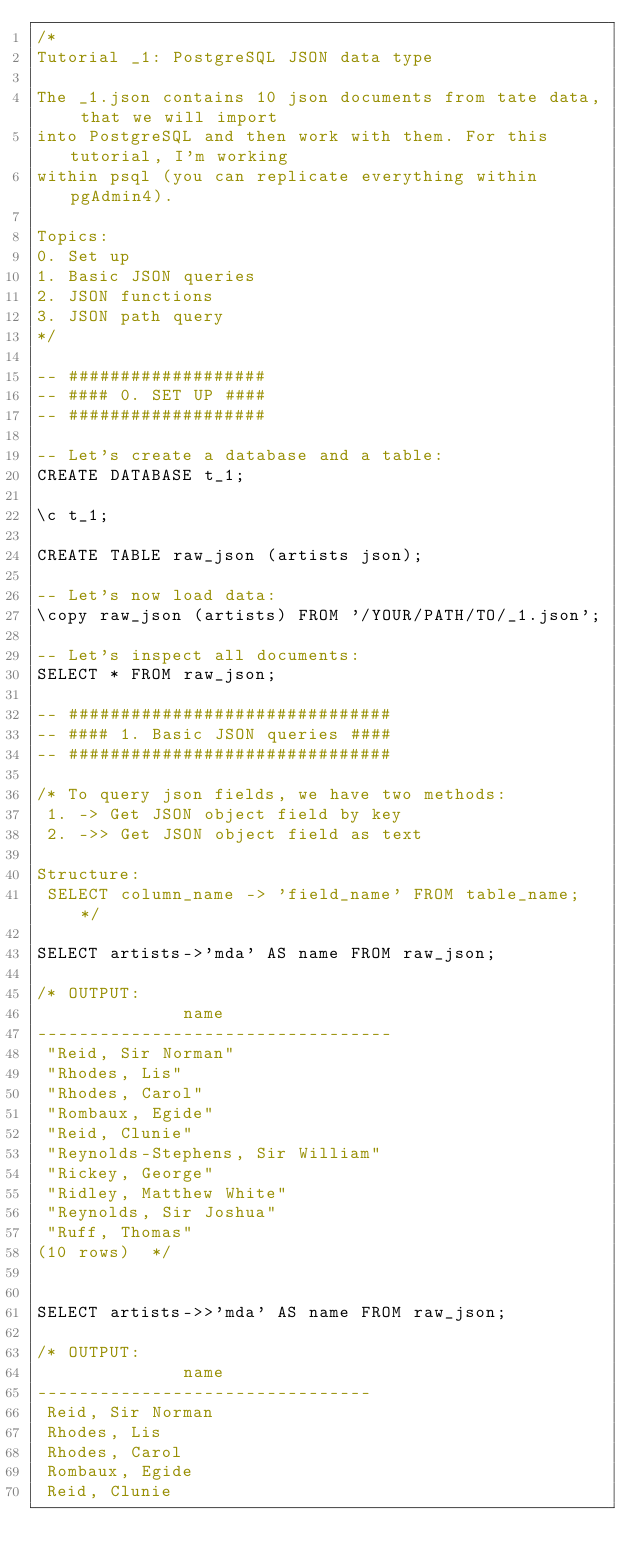Convert code to text. <code><loc_0><loc_0><loc_500><loc_500><_SQL_>/*
Tutorial _1: PostgreSQL JSON data type

The _1.json contains 10 json documents from tate data, that we will import
into PostgreSQL and then work with them. For this tutorial, I'm working
within psql (you can replicate everything within pgAdmin4).

Topics:
0. Set up
1. Basic JSON queries
2. JSON functions
3. JSON path query
*/

-- ###################
-- #### 0. SET UP ####
-- ###################

-- Let's create a database and a table:
CREATE DATABASE t_1;

\c t_1;

CREATE TABLE raw_json (artists json);

-- Let's now load data:
\copy raw_json (artists) FROM '/YOUR/PATH/TO/_1.json';

-- Let's inspect all documents:
SELECT * FROM raw_json;

-- ###############################
-- #### 1. Basic JSON queries ####
-- ###############################

/* To query json fields, we have two methods:
 1. -> Get JSON object field by key
 2. ->> Get JSON object field as text

Structure:
 SELECT column_name -> 'field_name' FROM table_name; */

SELECT artists->'mda' AS name FROM raw_json;

/* OUTPUT:
              name
----------------------------------
 "Reid, Sir Norman"
 "Rhodes, Lis"
 "Rhodes, Carol"
 "Rombaux, Egide"
 "Reid, Clunie"
 "Reynolds-Stephens, Sir William"
 "Rickey, George"
 "Ridley, Matthew White"
 "Reynolds, Sir Joshua"
 "Ruff, Thomas"
(10 rows)  */


SELECT artists->>'mda' AS name FROM raw_json;

/* OUTPUT:
              name
--------------------------------
 Reid, Sir Norman
 Rhodes, Lis
 Rhodes, Carol
 Rombaux, Egide
 Reid, Clunie</code> 